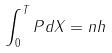<formula> <loc_0><loc_0><loc_500><loc_500>\int _ { 0 } ^ { T } P d X = n h</formula> 